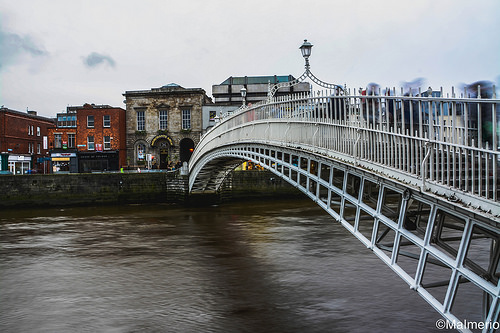<image>
Can you confirm if the building is to the left of the bridge? No. The building is not to the left of the bridge. From this viewpoint, they have a different horizontal relationship. 